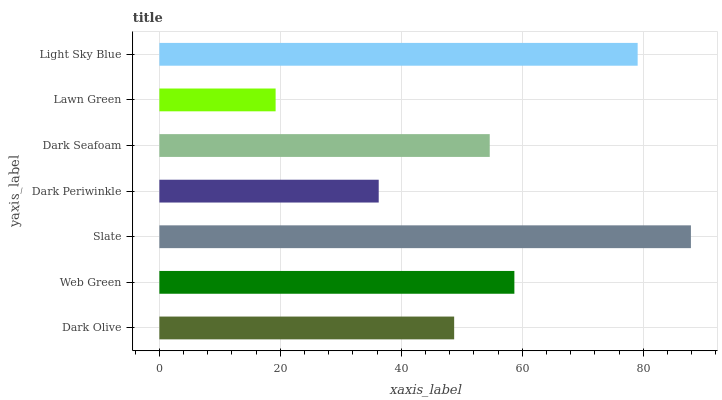Is Lawn Green the minimum?
Answer yes or no. Yes. Is Slate the maximum?
Answer yes or no. Yes. Is Web Green the minimum?
Answer yes or no. No. Is Web Green the maximum?
Answer yes or no. No. Is Web Green greater than Dark Olive?
Answer yes or no. Yes. Is Dark Olive less than Web Green?
Answer yes or no. Yes. Is Dark Olive greater than Web Green?
Answer yes or no. No. Is Web Green less than Dark Olive?
Answer yes or no. No. Is Dark Seafoam the high median?
Answer yes or no. Yes. Is Dark Seafoam the low median?
Answer yes or no. Yes. Is Lawn Green the high median?
Answer yes or no. No. Is Slate the low median?
Answer yes or no. No. 